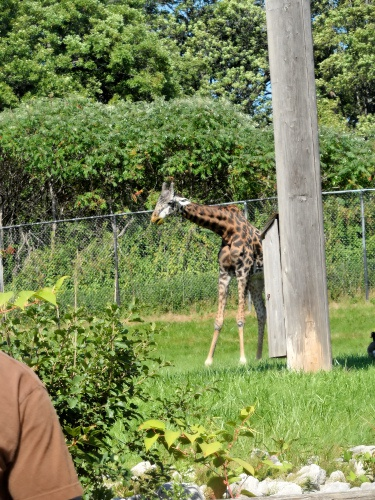Describe the objects in this image and their specific colors. I can see people in darkgreen, gray, tan, and black tones and giraffe in darkgreen, gray, black, and tan tones in this image. 